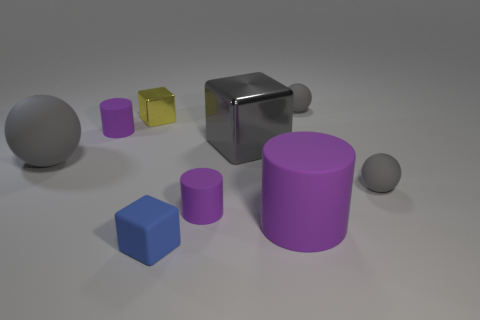Do the big shiny block and the large ball have the same color?
Your answer should be very brief. Yes. What material is the large thing that is the same color as the large cube?
Keep it short and to the point. Rubber. There is a tiny yellow metal block; are there any tiny blue things on the right side of it?
Offer a terse response. Yes. Is the number of purple rubber things greater than the number of green shiny cylinders?
Give a very brief answer. Yes. There is a small rubber cylinder that is to the left of the tiny purple rubber object that is in front of the small purple cylinder on the left side of the small blue matte object; what color is it?
Provide a succinct answer. Purple. There is a block that is made of the same material as the big gray ball; what color is it?
Your answer should be very brief. Blue. How many things are gray spheres behind the large gray matte object or rubber things behind the tiny blue cube?
Your answer should be very brief. 6. There is a gray sphere left of the large purple matte cylinder; does it have the same size as the gray matte ball behind the tiny yellow block?
Provide a succinct answer. No. The other big metallic thing that is the same shape as the yellow object is what color?
Your response must be concise. Gray. Is there any other thing that is the same shape as the large purple matte thing?
Offer a terse response. Yes. 